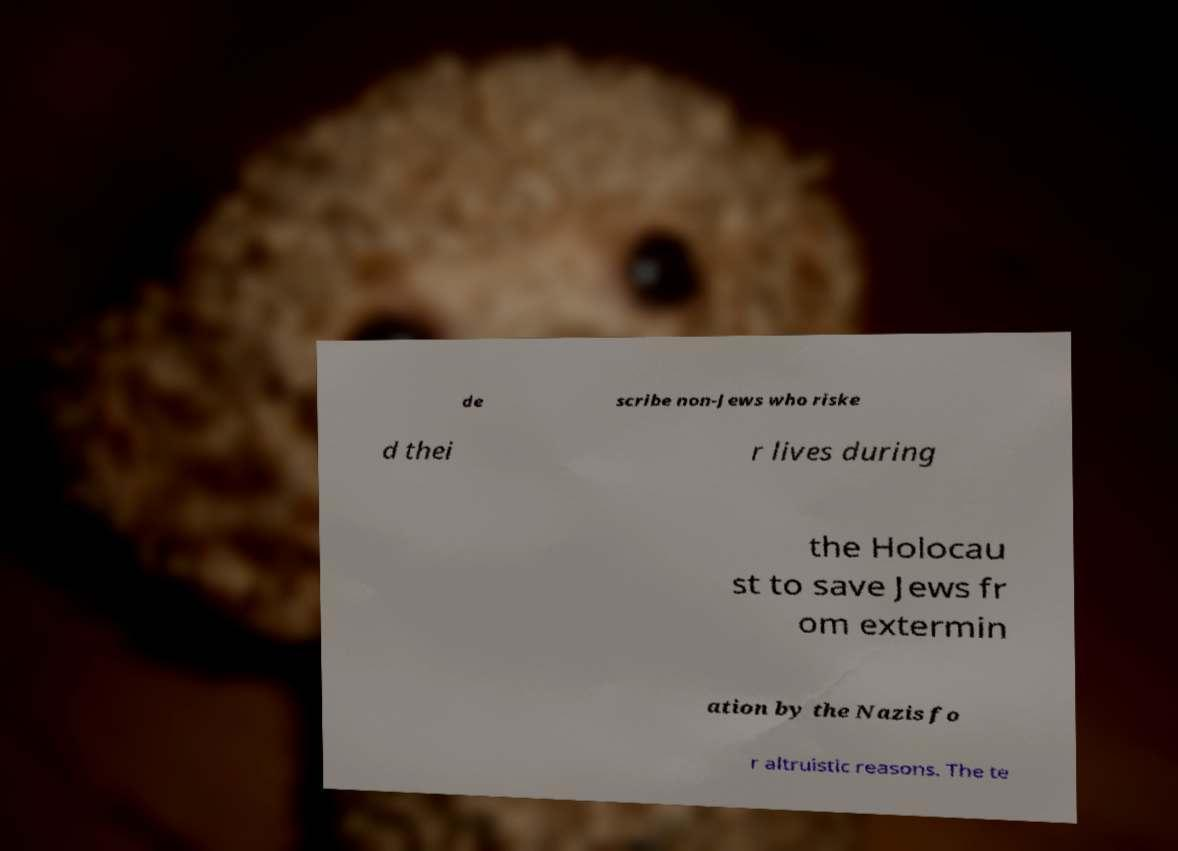Could you assist in decoding the text presented in this image and type it out clearly? de scribe non-Jews who riske d thei r lives during the Holocau st to save Jews fr om extermin ation by the Nazis fo r altruistic reasons. The te 